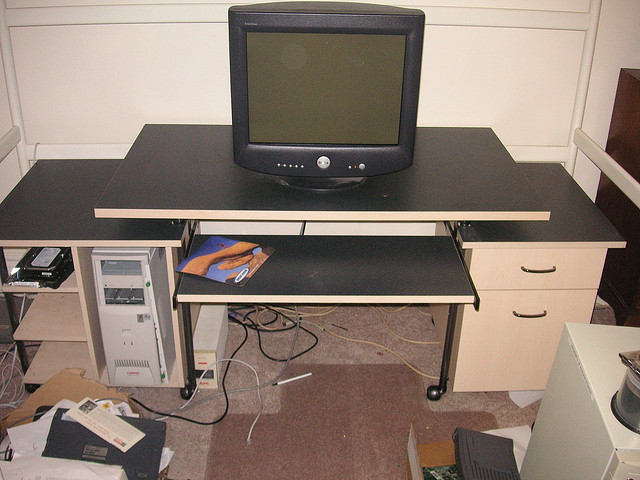What is on the floor next to the desk? Scattered on the floor next to the desk are various objects including loose papers, a couple of boxes, and what appears to be a stray cable or two. There is a sense of disorganization that suggests the room is perhaps in the process of being set up or cleaned. 